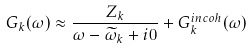<formula> <loc_0><loc_0><loc_500><loc_500>G _ { k } ( \omega ) \approx \frac { Z _ { k } } { \omega - \widetilde { \omega } _ { k } + i 0 } + G ^ { i n c o h } _ { k } ( \omega )</formula> 